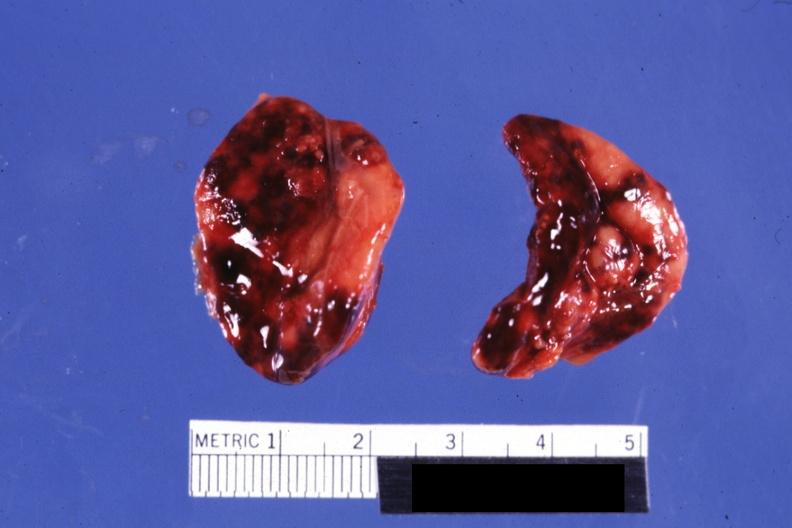does this image adrenal both adrenals external views focal hemorrhages do not know history looks like placental abruption?
Answer the question using a single word or phrase. Yes 